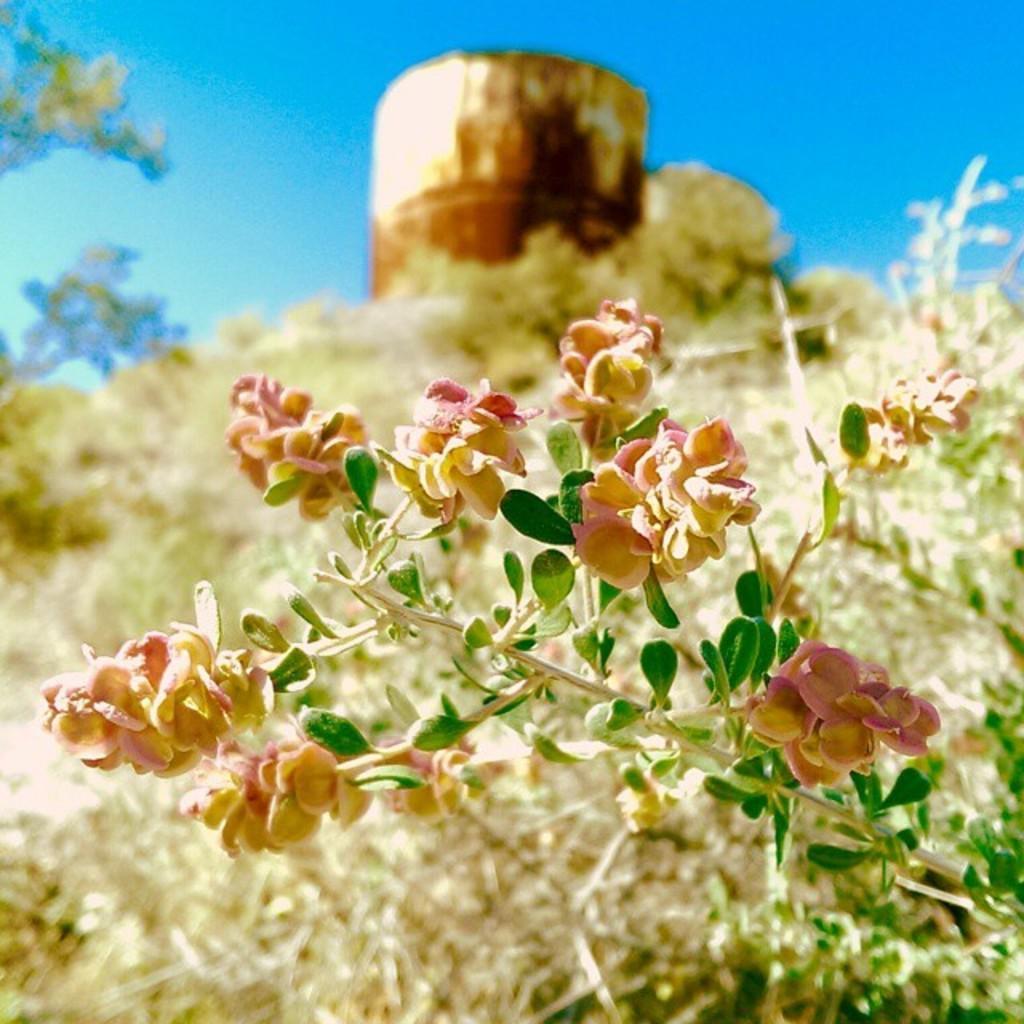Describe this image in one or two sentences. Here we can see a plant and flowers. There is a blur background and we can see trees, sky, and an object. 